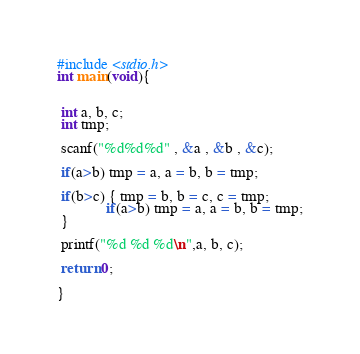<code> <loc_0><loc_0><loc_500><loc_500><_C_>
#include <stdio.h>
int main(void){


 int a, b, c;
 int tmp;
 
 scanf("%d%d%d" , &a , &b , &c);
 
 if(a>b) tmp = a, a = b, b = tmp;
 
 if(b>c) { tmp = b, b = c, c = tmp;
             if(a>b) tmp = a, a = b, b = tmp;
 }
 
 printf("%d %d %d\n",a, b, c);
   
 return 0;
    
}

</code> 